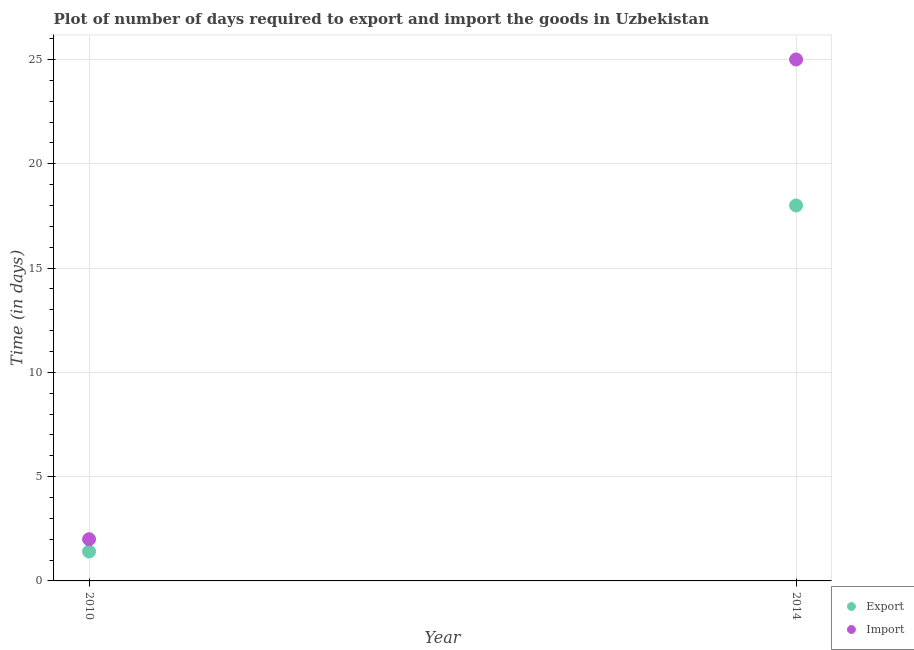How many different coloured dotlines are there?
Offer a terse response. 2. What is the time required to export in 2010?
Your response must be concise. 1.41. Across all years, what is the maximum time required to import?
Give a very brief answer. 25. Across all years, what is the minimum time required to import?
Offer a very short reply. 2. In which year was the time required to import maximum?
Make the answer very short. 2014. What is the total time required to import in the graph?
Give a very brief answer. 27. What is the difference between the time required to export in 2010 and that in 2014?
Provide a succinct answer. -16.59. What is the difference between the time required to export in 2010 and the time required to import in 2014?
Provide a short and direct response. -23.59. In the year 2010, what is the difference between the time required to import and time required to export?
Your answer should be very brief. 0.59. What is the ratio of the time required to import in 2010 to that in 2014?
Your response must be concise. 0.08. In how many years, is the time required to import greater than the average time required to import taken over all years?
Offer a very short reply. 1. Does the time required to import monotonically increase over the years?
Give a very brief answer. Yes. How many years are there in the graph?
Make the answer very short. 2. How are the legend labels stacked?
Your response must be concise. Vertical. What is the title of the graph?
Make the answer very short. Plot of number of days required to export and import the goods in Uzbekistan. What is the label or title of the Y-axis?
Offer a terse response. Time (in days). What is the Time (in days) of Export in 2010?
Your answer should be very brief. 1.41. What is the Time (in days) of Import in 2010?
Provide a succinct answer. 2. Across all years, what is the maximum Time (in days) in Export?
Provide a succinct answer. 18. Across all years, what is the maximum Time (in days) in Import?
Your response must be concise. 25. Across all years, what is the minimum Time (in days) in Export?
Ensure brevity in your answer.  1.41. What is the total Time (in days) of Export in the graph?
Your answer should be compact. 19.41. What is the difference between the Time (in days) of Export in 2010 and that in 2014?
Your answer should be compact. -16.59. What is the difference between the Time (in days) in Export in 2010 and the Time (in days) in Import in 2014?
Give a very brief answer. -23.59. What is the average Time (in days) of Export per year?
Provide a succinct answer. 9.71. In the year 2010, what is the difference between the Time (in days) in Export and Time (in days) in Import?
Your response must be concise. -0.59. What is the ratio of the Time (in days) of Export in 2010 to that in 2014?
Make the answer very short. 0.08. What is the difference between the highest and the second highest Time (in days) in Export?
Provide a short and direct response. 16.59. What is the difference between the highest and the lowest Time (in days) in Export?
Keep it short and to the point. 16.59. What is the difference between the highest and the lowest Time (in days) in Import?
Make the answer very short. 23. 